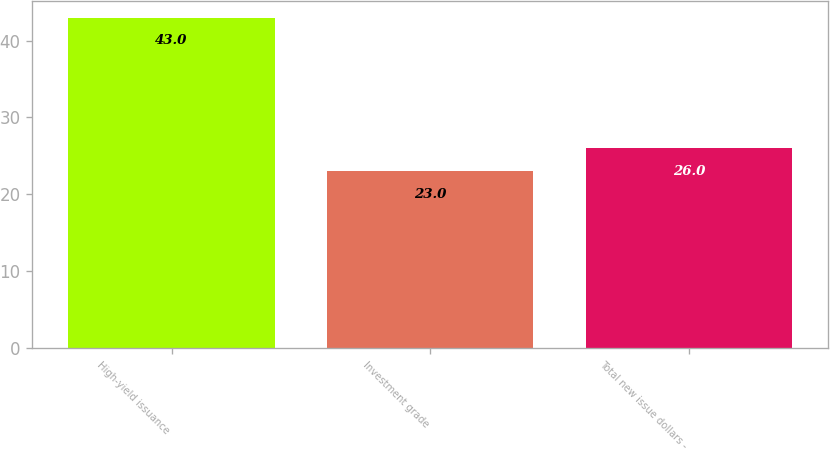<chart> <loc_0><loc_0><loc_500><loc_500><bar_chart><fcel>High-yield issuance<fcel>Investment grade<fcel>Total new issue dollars -<nl><fcel>43<fcel>23<fcel>26<nl></chart> 